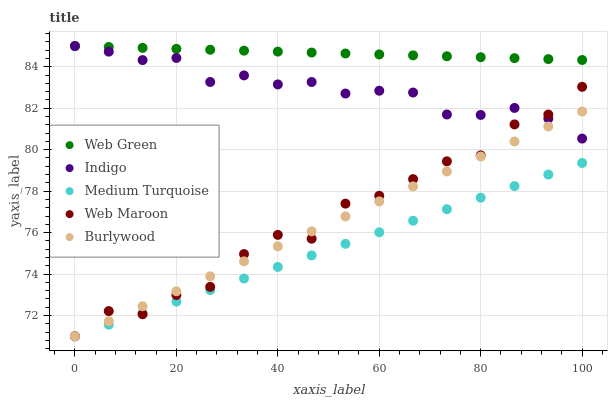Does Medium Turquoise have the minimum area under the curve?
Answer yes or no. Yes. Does Web Green have the maximum area under the curve?
Answer yes or no. Yes. Does Web Maroon have the minimum area under the curve?
Answer yes or no. No. Does Web Maroon have the maximum area under the curve?
Answer yes or no. No. Is Burlywood the smoothest?
Answer yes or no. Yes. Is Web Maroon the roughest?
Answer yes or no. Yes. Is Indigo the smoothest?
Answer yes or no. No. Is Indigo the roughest?
Answer yes or no. No. Does Burlywood have the lowest value?
Answer yes or no. Yes. Does Indigo have the lowest value?
Answer yes or no. No. Does Web Green have the highest value?
Answer yes or no. Yes. Does Web Maroon have the highest value?
Answer yes or no. No. Is Burlywood less than Web Green?
Answer yes or no. Yes. Is Web Green greater than Burlywood?
Answer yes or no. Yes. Does Indigo intersect Burlywood?
Answer yes or no. Yes. Is Indigo less than Burlywood?
Answer yes or no. No. Is Indigo greater than Burlywood?
Answer yes or no. No. Does Burlywood intersect Web Green?
Answer yes or no. No. 